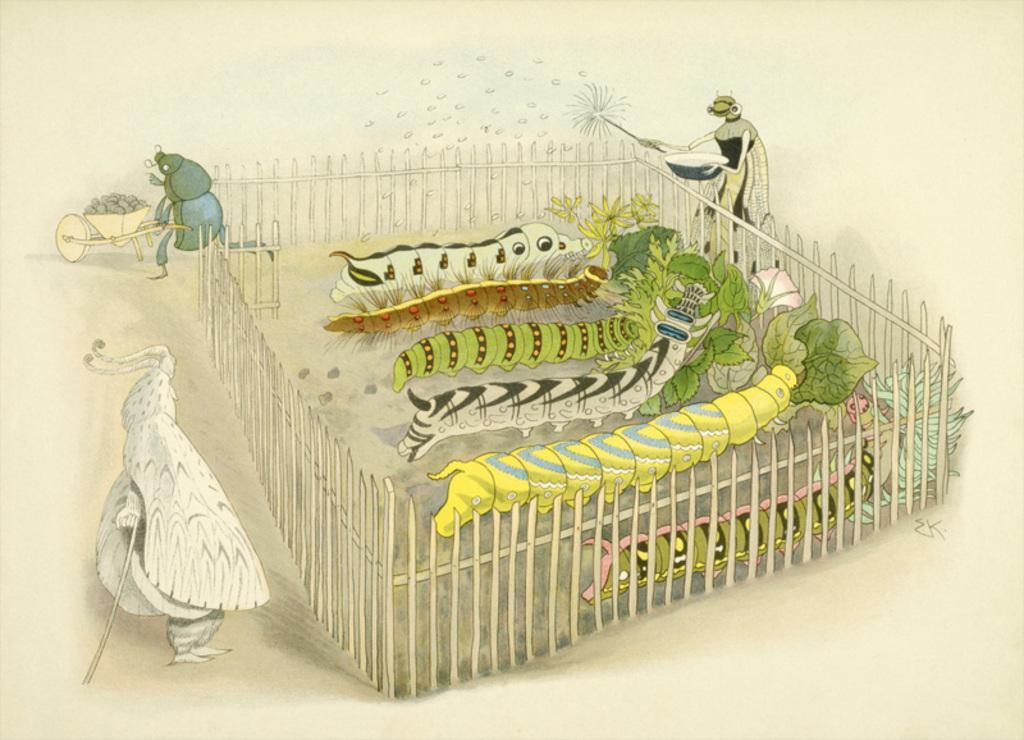How would you summarize this image in a sentence or two? In the center of the image we can see worms and there are plants. There is a fence and we can see a trolley. There are flies. 